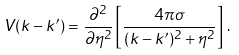<formula> <loc_0><loc_0><loc_500><loc_500>V ( { k } - { k } ^ { \prime } ) = \frac { \partial ^ { 2 } } { \partial \eta ^ { 2 } } \left [ \frac { 4 \pi \sigma } { ( { k } - { k } ^ { \prime } ) ^ { 2 } + \eta ^ { 2 } } \right ] \, .</formula> 